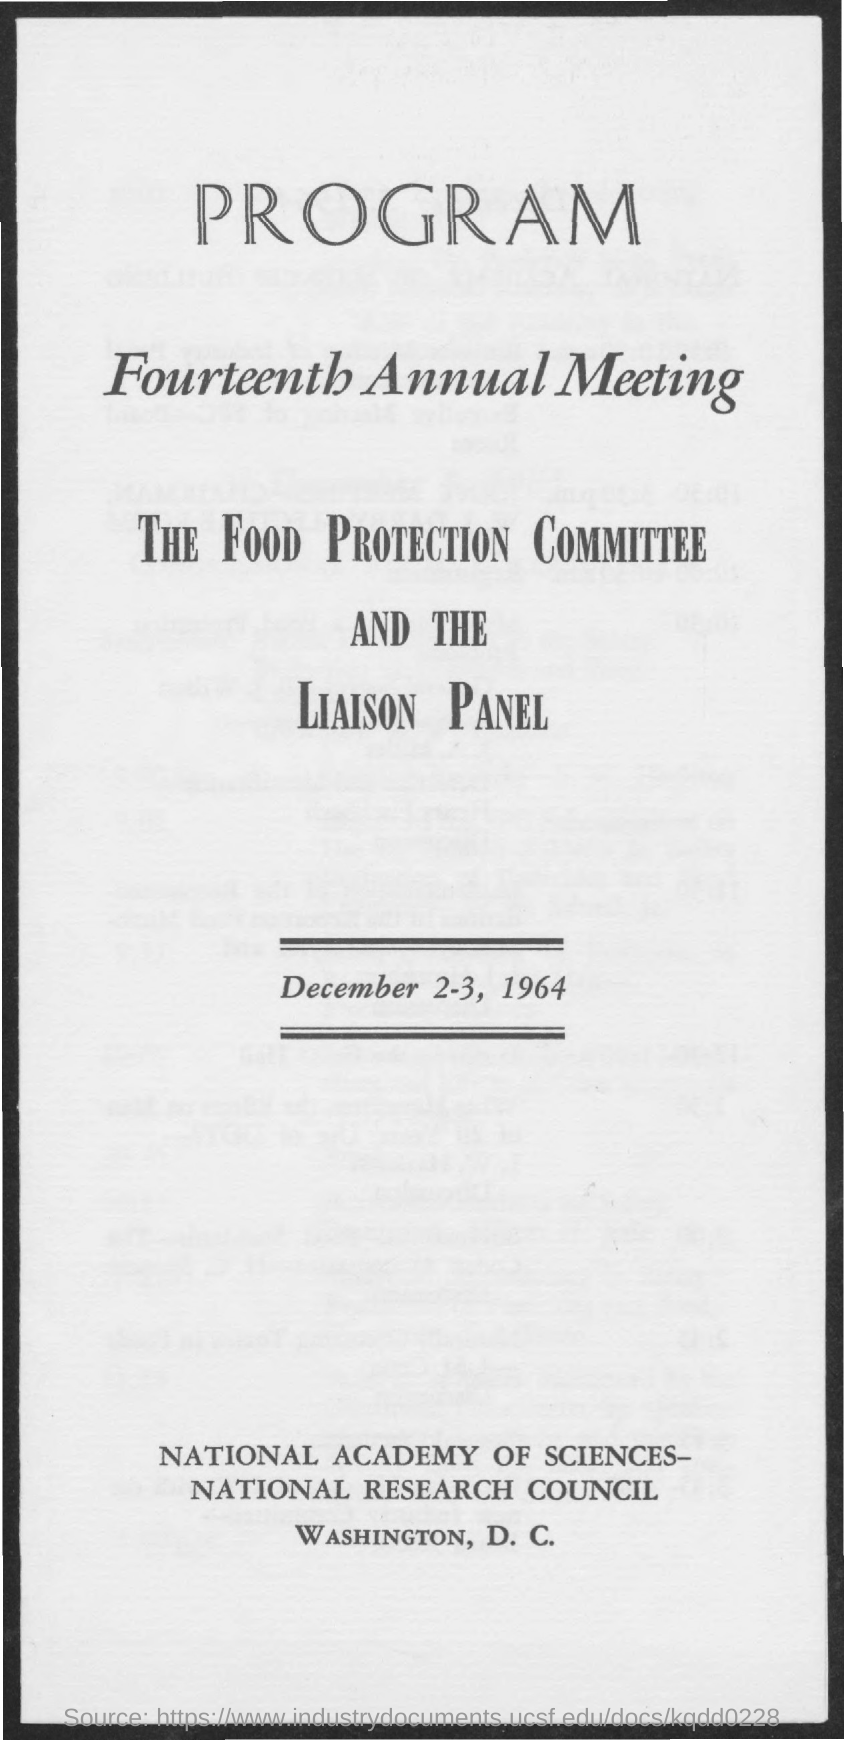Indicate a few pertinent items in this graphic. The third title in the document is 'The Food Protection Committee and the Liaison Panel.' 